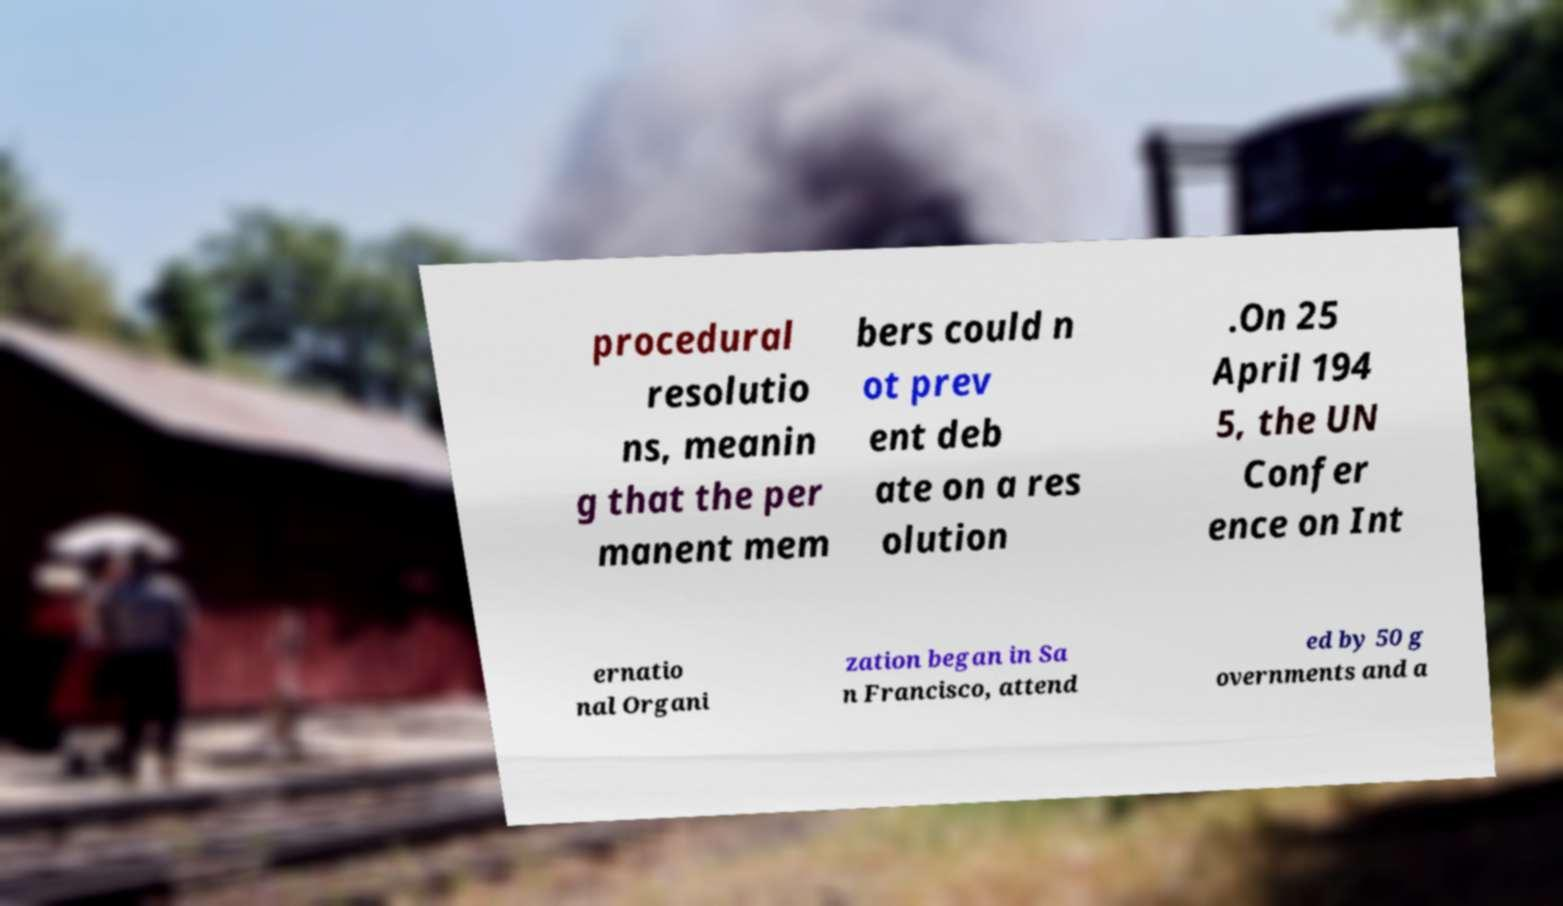Can you accurately transcribe the text from the provided image for me? procedural resolutio ns, meanin g that the per manent mem bers could n ot prev ent deb ate on a res olution .On 25 April 194 5, the UN Confer ence on Int ernatio nal Organi zation began in Sa n Francisco, attend ed by 50 g overnments and a 